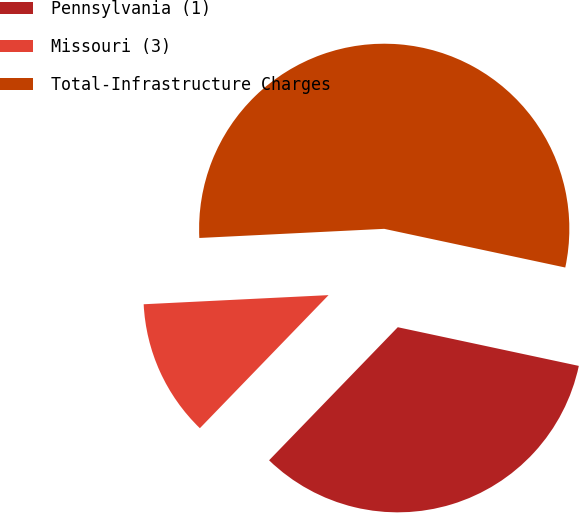Convert chart. <chart><loc_0><loc_0><loc_500><loc_500><pie_chart><fcel>Pennsylvania (1)<fcel>Missouri (3)<fcel>Total-Infrastructure Charges<nl><fcel>33.88%<fcel>11.98%<fcel>54.13%<nl></chart> 